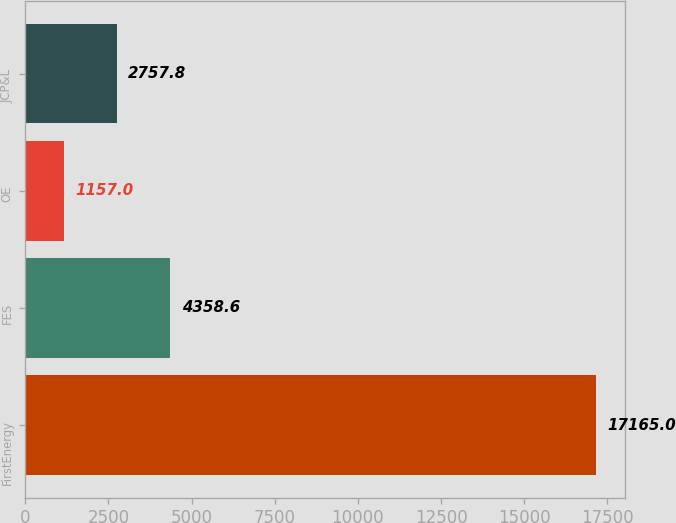<chart> <loc_0><loc_0><loc_500><loc_500><bar_chart><fcel>FirstEnergy<fcel>FES<fcel>OE<fcel>JCP&L<nl><fcel>17165<fcel>4358.6<fcel>1157<fcel>2757.8<nl></chart> 